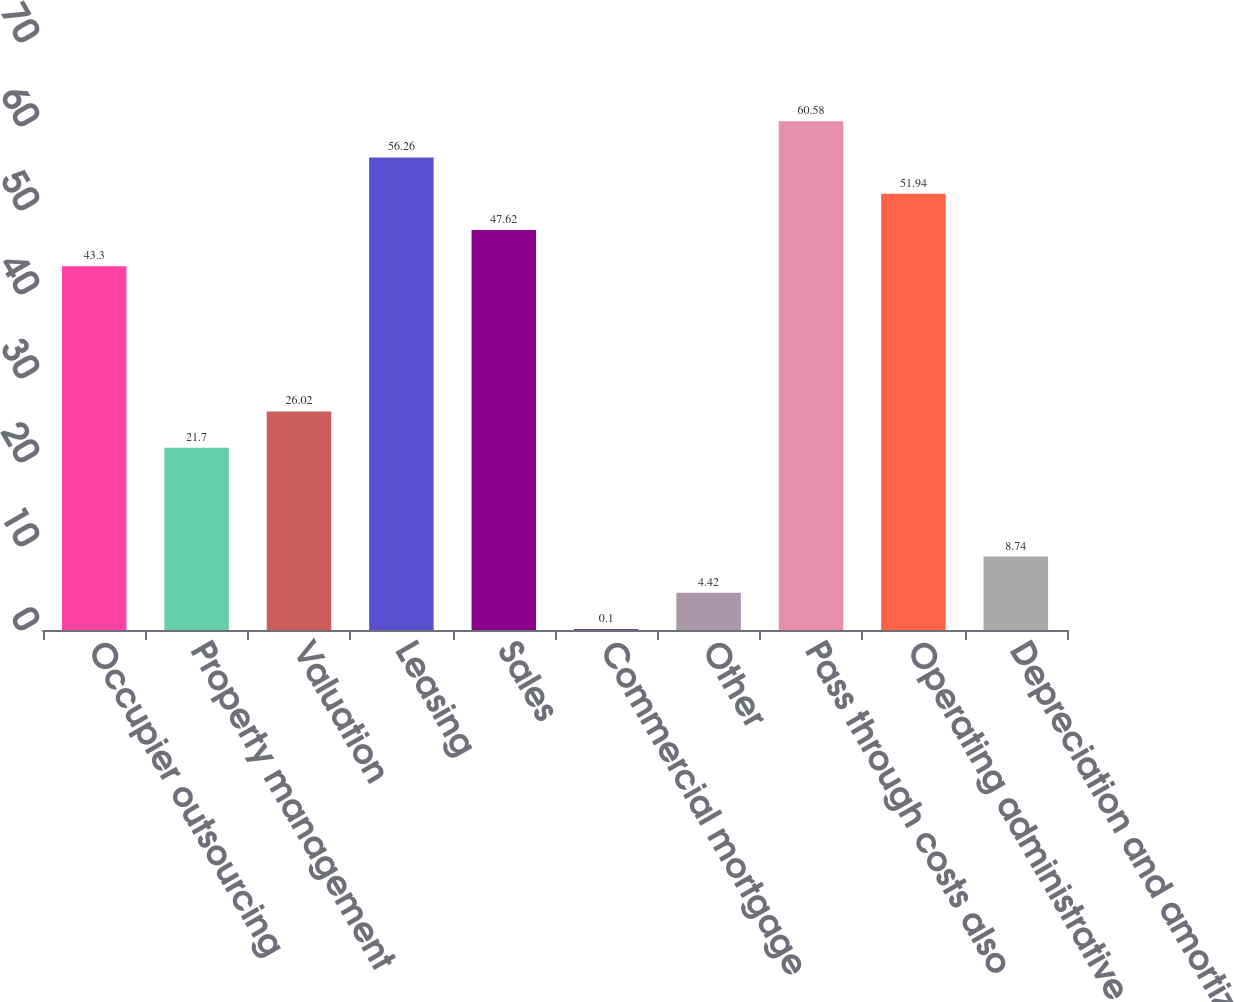Convert chart to OTSL. <chart><loc_0><loc_0><loc_500><loc_500><bar_chart><fcel>Occupier outsourcing<fcel>Property management<fcel>Valuation<fcel>Leasing<fcel>Sales<fcel>Commercial mortgage<fcel>Other<fcel>Pass through costs also<fcel>Operating administrative and<fcel>Depreciation and amortization<nl><fcel>43.3<fcel>21.7<fcel>26.02<fcel>56.26<fcel>47.62<fcel>0.1<fcel>4.42<fcel>60.58<fcel>51.94<fcel>8.74<nl></chart> 